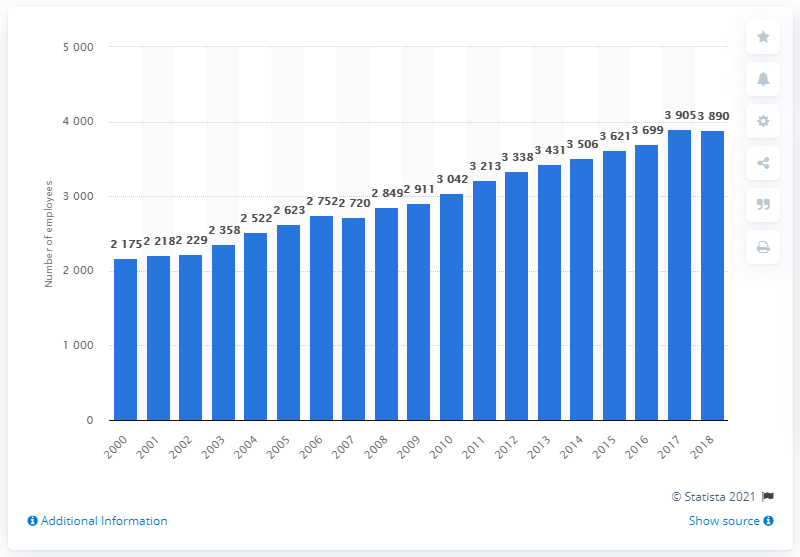Outline some significant characteristics in this image. In 2018, there were 3,890 physiotherapists employed in Austria. 